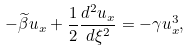Convert formula to latex. <formula><loc_0><loc_0><loc_500><loc_500>- \widetilde { \beta } u _ { x } + \frac { 1 } { 2 } \frac { d ^ { 2 } u _ { x } } { d \xi ^ { 2 } } = - \gamma u _ { x } ^ { 3 } ,</formula> 